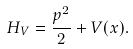Convert formula to latex. <formula><loc_0><loc_0><loc_500><loc_500>H _ { V } = \frac { p ^ { 2 } } { 2 } + V ( x ) .</formula> 